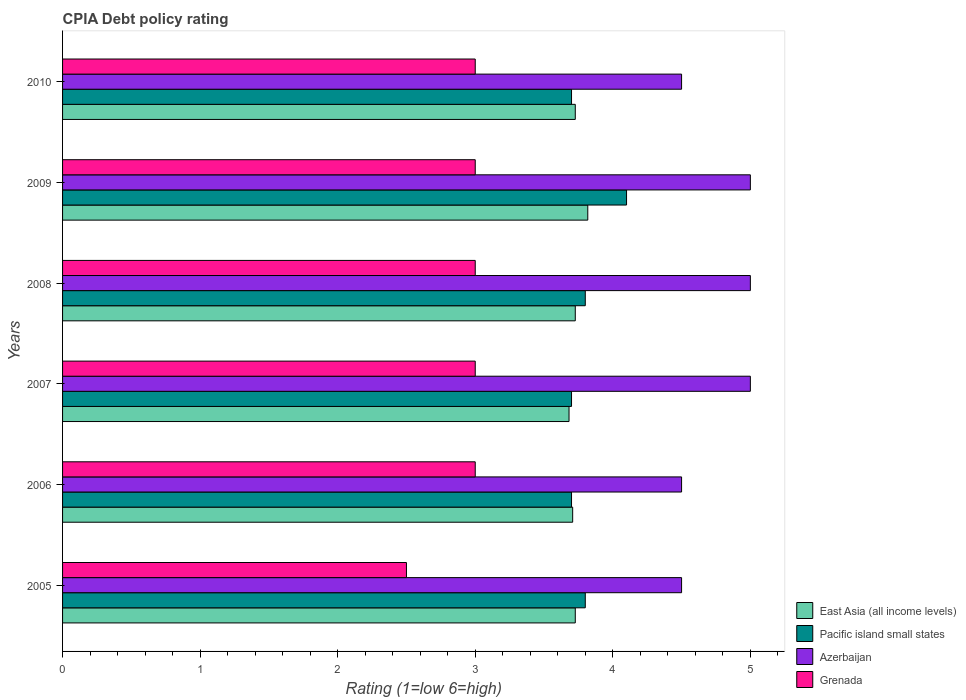How many different coloured bars are there?
Keep it short and to the point. 4. Are the number of bars per tick equal to the number of legend labels?
Make the answer very short. Yes. Are the number of bars on each tick of the Y-axis equal?
Your answer should be very brief. Yes. How many bars are there on the 2nd tick from the bottom?
Your response must be concise. 4. What is the label of the 4th group of bars from the top?
Give a very brief answer. 2007. In how many cases, is the number of bars for a given year not equal to the number of legend labels?
Your response must be concise. 0. In which year was the CPIA rating in Grenada minimum?
Keep it short and to the point. 2005. What is the total CPIA rating in Pacific island small states in the graph?
Your answer should be very brief. 22.8. What is the difference between the CPIA rating in Grenada in 2010 and the CPIA rating in East Asia (all income levels) in 2007?
Give a very brief answer. -0.68. What is the average CPIA rating in Grenada per year?
Provide a short and direct response. 2.92. In the year 2007, what is the difference between the CPIA rating in Azerbaijan and CPIA rating in Pacific island small states?
Offer a very short reply. 1.3. In how many years, is the CPIA rating in Grenada greater than 2.8 ?
Keep it short and to the point. 5. What is the ratio of the CPIA rating in Azerbaijan in 2009 to that in 2010?
Offer a terse response. 1.11. Is the CPIA rating in Grenada in 2005 less than that in 2007?
Offer a very short reply. Yes. What is the difference between the highest and the second highest CPIA rating in Pacific island small states?
Your answer should be compact. 0.3. Is it the case that in every year, the sum of the CPIA rating in East Asia (all income levels) and CPIA rating in Azerbaijan is greater than the sum of CPIA rating in Grenada and CPIA rating in Pacific island small states?
Your answer should be compact. Yes. What does the 3rd bar from the top in 2007 represents?
Make the answer very short. Pacific island small states. What does the 1st bar from the bottom in 2005 represents?
Provide a succinct answer. East Asia (all income levels). What is the difference between two consecutive major ticks on the X-axis?
Provide a succinct answer. 1. Are the values on the major ticks of X-axis written in scientific E-notation?
Give a very brief answer. No. Does the graph contain any zero values?
Keep it short and to the point. No. Where does the legend appear in the graph?
Make the answer very short. Bottom right. How many legend labels are there?
Ensure brevity in your answer.  4. What is the title of the graph?
Your answer should be very brief. CPIA Debt policy rating. What is the label or title of the Y-axis?
Keep it short and to the point. Years. What is the Rating (1=low 6=high) in East Asia (all income levels) in 2005?
Keep it short and to the point. 3.73. What is the Rating (1=low 6=high) in Pacific island small states in 2005?
Your answer should be compact. 3.8. What is the Rating (1=low 6=high) of East Asia (all income levels) in 2006?
Ensure brevity in your answer.  3.71. What is the Rating (1=low 6=high) of Grenada in 2006?
Give a very brief answer. 3. What is the Rating (1=low 6=high) of East Asia (all income levels) in 2007?
Your response must be concise. 3.68. What is the Rating (1=low 6=high) in Pacific island small states in 2007?
Make the answer very short. 3.7. What is the Rating (1=low 6=high) in Azerbaijan in 2007?
Offer a terse response. 5. What is the Rating (1=low 6=high) in East Asia (all income levels) in 2008?
Your answer should be compact. 3.73. What is the Rating (1=low 6=high) of Pacific island small states in 2008?
Provide a short and direct response. 3.8. What is the Rating (1=low 6=high) in Grenada in 2008?
Your response must be concise. 3. What is the Rating (1=low 6=high) in East Asia (all income levels) in 2009?
Your answer should be very brief. 3.82. What is the Rating (1=low 6=high) of Pacific island small states in 2009?
Offer a terse response. 4.1. What is the Rating (1=low 6=high) of Azerbaijan in 2009?
Your response must be concise. 5. What is the Rating (1=low 6=high) of Grenada in 2009?
Your response must be concise. 3. What is the Rating (1=low 6=high) in East Asia (all income levels) in 2010?
Offer a very short reply. 3.73. What is the Rating (1=low 6=high) of Azerbaijan in 2010?
Your answer should be compact. 4.5. What is the Rating (1=low 6=high) in Grenada in 2010?
Keep it short and to the point. 3. Across all years, what is the maximum Rating (1=low 6=high) of East Asia (all income levels)?
Give a very brief answer. 3.82. Across all years, what is the maximum Rating (1=low 6=high) of Pacific island small states?
Your answer should be compact. 4.1. Across all years, what is the minimum Rating (1=low 6=high) of East Asia (all income levels)?
Offer a very short reply. 3.68. Across all years, what is the minimum Rating (1=low 6=high) of Grenada?
Provide a short and direct response. 2.5. What is the total Rating (1=low 6=high) in East Asia (all income levels) in the graph?
Keep it short and to the point. 22.39. What is the total Rating (1=low 6=high) in Pacific island small states in the graph?
Ensure brevity in your answer.  22.8. What is the total Rating (1=low 6=high) of Azerbaijan in the graph?
Provide a short and direct response. 28.5. What is the total Rating (1=low 6=high) of Grenada in the graph?
Ensure brevity in your answer.  17.5. What is the difference between the Rating (1=low 6=high) in East Asia (all income levels) in 2005 and that in 2006?
Your answer should be compact. 0.02. What is the difference between the Rating (1=low 6=high) in East Asia (all income levels) in 2005 and that in 2007?
Keep it short and to the point. 0.05. What is the difference between the Rating (1=low 6=high) in Pacific island small states in 2005 and that in 2007?
Your answer should be compact. 0.1. What is the difference between the Rating (1=low 6=high) of Azerbaijan in 2005 and that in 2007?
Give a very brief answer. -0.5. What is the difference between the Rating (1=low 6=high) of East Asia (all income levels) in 2005 and that in 2008?
Provide a succinct answer. 0. What is the difference between the Rating (1=low 6=high) of Pacific island small states in 2005 and that in 2008?
Your answer should be compact. 0. What is the difference between the Rating (1=low 6=high) of Grenada in 2005 and that in 2008?
Provide a short and direct response. -0.5. What is the difference between the Rating (1=low 6=high) in East Asia (all income levels) in 2005 and that in 2009?
Make the answer very short. -0.09. What is the difference between the Rating (1=low 6=high) in Grenada in 2005 and that in 2009?
Keep it short and to the point. -0.5. What is the difference between the Rating (1=low 6=high) in Pacific island small states in 2005 and that in 2010?
Your response must be concise. 0.1. What is the difference between the Rating (1=low 6=high) in Azerbaijan in 2005 and that in 2010?
Offer a terse response. 0. What is the difference between the Rating (1=low 6=high) in Grenada in 2005 and that in 2010?
Your answer should be compact. -0.5. What is the difference between the Rating (1=low 6=high) of East Asia (all income levels) in 2006 and that in 2007?
Ensure brevity in your answer.  0.03. What is the difference between the Rating (1=low 6=high) in East Asia (all income levels) in 2006 and that in 2008?
Your answer should be compact. -0.02. What is the difference between the Rating (1=low 6=high) in Pacific island small states in 2006 and that in 2008?
Provide a succinct answer. -0.1. What is the difference between the Rating (1=low 6=high) in Azerbaijan in 2006 and that in 2008?
Offer a very short reply. -0.5. What is the difference between the Rating (1=low 6=high) in East Asia (all income levels) in 2006 and that in 2009?
Provide a short and direct response. -0.11. What is the difference between the Rating (1=low 6=high) in Grenada in 2006 and that in 2009?
Your answer should be compact. 0. What is the difference between the Rating (1=low 6=high) in East Asia (all income levels) in 2006 and that in 2010?
Your answer should be compact. -0.02. What is the difference between the Rating (1=low 6=high) in Azerbaijan in 2006 and that in 2010?
Make the answer very short. 0. What is the difference between the Rating (1=low 6=high) in Grenada in 2006 and that in 2010?
Make the answer very short. 0. What is the difference between the Rating (1=low 6=high) in East Asia (all income levels) in 2007 and that in 2008?
Your answer should be compact. -0.05. What is the difference between the Rating (1=low 6=high) in Azerbaijan in 2007 and that in 2008?
Provide a short and direct response. 0. What is the difference between the Rating (1=low 6=high) in East Asia (all income levels) in 2007 and that in 2009?
Provide a short and direct response. -0.14. What is the difference between the Rating (1=low 6=high) in Azerbaijan in 2007 and that in 2009?
Your answer should be compact. 0. What is the difference between the Rating (1=low 6=high) of East Asia (all income levels) in 2007 and that in 2010?
Provide a succinct answer. -0.05. What is the difference between the Rating (1=low 6=high) in Azerbaijan in 2007 and that in 2010?
Provide a succinct answer. 0.5. What is the difference between the Rating (1=low 6=high) of East Asia (all income levels) in 2008 and that in 2009?
Keep it short and to the point. -0.09. What is the difference between the Rating (1=low 6=high) of Pacific island small states in 2008 and that in 2009?
Keep it short and to the point. -0.3. What is the difference between the Rating (1=low 6=high) of Azerbaijan in 2008 and that in 2009?
Your response must be concise. 0. What is the difference between the Rating (1=low 6=high) in Grenada in 2008 and that in 2009?
Give a very brief answer. 0. What is the difference between the Rating (1=low 6=high) in Pacific island small states in 2008 and that in 2010?
Ensure brevity in your answer.  0.1. What is the difference between the Rating (1=low 6=high) of Grenada in 2008 and that in 2010?
Give a very brief answer. 0. What is the difference between the Rating (1=low 6=high) in East Asia (all income levels) in 2009 and that in 2010?
Your response must be concise. 0.09. What is the difference between the Rating (1=low 6=high) of East Asia (all income levels) in 2005 and the Rating (1=low 6=high) of Pacific island small states in 2006?
Make the answer very short. 0.03. What is the difference between the Rating (1=low 6=high) of East Asia (all income levels) in 2005 and the Rating (1=low 6=high) of Azerbaijan in 2006?
Offer a terse response. -0.77. What is the difference between the Rating (1=low 6=high) of East Asia (all income levels) in 2005 and the Rating (1=low 6=high) of Grenada in 2006?
Ensure brevity in your answer.  0.73. What is the difference between the Rating (1=low 6=high) in Pacific island small states in 2005 and the Rating (1=low 6=high) in Grenada in 2006?
Your answer should be compact. 0.8. What is the difference between the Rating (1=low 6=high) of East Asia (all income levels) in 2005 and the Rating (1=low 6=high) of Pacific island small states in 2007?
Provide a short and direct response. 0.03. What is the difference between the Rating (1=low 6=high) in East Asia (all income levels) in 2005 and the Rating (1=low 6=high) in Azerbaijan in 2007?
Your answer should be very brief. -1.27. What is the difference between the Rating (1=low 6=high) in East Asia (all income levels) in 2005 and the Rating (1=low 6=high) in Grenada in 2007?
Your answer should be very brief. 0.73. What is the difference between the Rating (1=low 6=high) in Pacific island small states in 2005 and the Rating (1=low 6=high) in Azerbaijan in 2007?
Ensure brevity in your answer.  -1.2. What is the difference between the Rating (1=low 6=high) of East Asia (all income levels) in 2005 and the Rating (1=low 6=high) of Pacific island small states in 2008?
Give a very brief answer. -0.07. What is the difference between the Rating (1=low 6=high) in East Asia (all income levels) in 2005 and the Rating (1=low 6=high) in Azerbaijan in 2008?
Keep it short and to the point. -1.27. What is the difference between the Rating (1=low 6=high) in East Asia (all income levels) in 2005 and the Rating (1=low 6=high) in Grenada in 2008?
Offer a terse response. 0.73. What is the difference between the Rating (1=low 6=high) in Pacific island small states in 2005 and the Rating (1=low 6=high) in Grenada in 2008?
Make the answer very short. 0.8. What is the difference between the Rating (1=low 6=high) of East Asia (all income levels) in 2005 and the Rating (1=low 6=high) of Pacific island small states in 2009?
Give a very brief answer. -0.37. What is the difference between the Rating (1=low 6=high) of East Asia (all income levels) in 2005 and the Rating (1=low 6=high) of Azerbaijan in 2009?
Give a very brief answer. -1.27. What is the difference between the Rating (1=low 6=high) in East Asia (all income levels) in 2005 and the Rating (1=low 6=high) in Grenada in 2009?
Your answer should be very brief. 0.73. What is the difference between the Rating (1=low 6=high) in Pacific island small states in 2005 and the Rating (1=low 6=high) in Azerbaijan in 2009?
Keep it short and to the point. -1.2. What is the difference between the Rating (1=low 6=high) of Pacific island small states in 2005 and the Rating (1=low 6=high) of Grenada in 2009?
Offer a terse response. 0.8. What is the difference between the Rating (1=low 6=high) of Azerbaijan in 2005 and the Rating (1=low 6=high) of Grenada in 2009?
Make the answer very short. 1.5. What is the difference between the Rating (1=low 6=high) in East Asia (all income levels) in 2005 and the Rating (1=low 6=high) in Pacific island small states in 2010?
Provide a short and direct response. 0.03. What is the difference between the Rating (1=low 6=high) in East Asia (all income levels) in 2005 and the Rating (1=low 6=high) in Azerbaijan in 2010?
Your answer should be very brief. -0.77. What is the difference between the Rating (1=low 6=high) of East Asia (all income levels) in 2005 and the Rating (1=low 6=high) of Grenada in 2010?
Provide a short and direct response. 0.73. What is the difference between the Rating (1=low 6=high) in East Asia (all income levels) in 2006 and the Rating (1=low 6=high) in Pacific island small states in 2007?
Your answer should be compact. 0.01. What is the difference between the Rating (1=low 6=high) in East Asia (all income levels) in 2006 and the Rating (1=low 6=high) in Azerbaijan in 2007?
Make the answer very short. -1.29. What is the difference between the Rating (1=low 6=high) of East Asia (all income levels) in 2006 and the Rating (1=low 6=high) of Grenada in 2007?
Offer a terse response. 0.71. What is the difference between the Rating (1=low 6=high) in Pacific island small states in 2006 and the Rating (1=low 6=high) in Grenada in 2007?
Offer a very short reply. 0.7. What is the difference between the Rating (1=low 6=high) of East Asia (all income levels) in 2006 and the Rating (1=low 6=high) of Pacific island small states in 2008?
Your response must be concise. -0.09. What is the difference between the Rating (1=low 6=high) of East Asia (all income levels) in 2006 and the Rating (1=low 6=high) of Azerbaijan in 2008?
Keep it short and to the point. -1.29. What is the difference between the Rating (1=low 6=high) in East Asia (all income levels) in 2006 and the Rating (1=low 6=high) in Grenada in 2008?
Provide a short and direct response. 0.71. What is the difference between the Rating (1=low 6=high) in East Asia (all income levels) in 2006 and the Rating (1=low 6=high) in Pacific island small states in 2009?
Keep it short and to the point. -0.39. What is the difference between the Rating (1=low 6=high) of East Asia (all income levels) in 2006 and the Rating (1=low 6=high) of Azerbaijan in 2009?
Make the answer very short. -1.29. What is the difference between the Rating (1=low 6=high) in East Asia (all income levels) in 2006 and the Rating (1=low 6=high) in Grenada in 2009?
Your response must be concise. 0.71. What is the difference between the Rating (1=low 6=high) of East Asia (all income levels) in 2006 and the Rating (1=low 6=high) of Pacific island small states in 2010?
Keep it short and to the point. 0.01. What is the difference between the Rating (1=low 6=high) in East Asia (all income levels) in 2006 and the Rating (1=low 6=high) in Azerbaijan in 2010?
Keep it short and to the point. -0.79. What is the difference between the Rating (1=low 6=high) of East Asia (all income levels) in 2006 and the Rating (1=low 6=high) of Grenada in 2010?
Provide a succinct answer. 0.71. What is the difference between the Rating (1=low 6=high) of Pacific island small states in 2006 and the Rating (1=low 6=high) of Azerbaijan in 2010?
Your answer should be compact. -0.8. What is the difference between the Rating (1=low 6=high) in Pacific island small states in 2006 and the Rating (1=low 6=high) in Grenada in 2010?
Your response must be concise. 0.7. What is the difference between the Rating (1=low 6=high) of East Asia (all income levels) in 2007 and the Rating (1=low 6=high) of Pacific island small states in 2008?
Your answer should be compact. -0.12. What is the difference between the Rating (1=low 6=high) in East Asia (all income levels) in 2007 and the Rating (1=low 6=high) in Azerbaijan in 2008?
Your response must be concise. -1.32. What is the difference between the Rating (1=low 6=high) in East Asia (all income levels) in 2007 and the Rating (1=low 6=high) in Grenada in 2008?
Offer a very short reply. 0.68. What is the difference between the Rating (1=low 6=high) in Pacific island small states in 2007 and the Rating (1=low 6=high) in Azerbaijan in 2008?
Offer a terse response. -1.3. What is the difference between the Rating (1=low 6=high) of East Asia (all income levels) in 2007 and the Rating (1=low 6=high) of Pacific island small states in 2009?
Keep it short and to the point. -0.42. What is the difference between the Rating (1=low 6=high) of East Asia (all income levels) in 2007 and the Rating (1=low 6=high) of Azerbaijan in 2009?
Your response must be concise. -1.32. What is the difference between the Rating (1=low 6=high) of East Asia (all income levels) in 2007 and the Rating (1=low 6=high) of Grenada in 2009?
Your answer should be very brief. 0.68. What is the difference between the Rating (1=low 6=high) in Pacific island small states in 2007 and the Rating (1=low 6=high) in Grenada in 2009?
Keep it short and to the point. 0.7. What is the difference between the Rating (1=low 6=high) in East Asia (all income levels) in 2007 and the Rating (1=low 6=high) in Pacific island small states in 2010?
Offer a terse response. -0.02. What is the difference between the Rating (1=low 6=high) in East Asia (all income levels) in 2007 and the Rating (1=low 6=high) in Azerbaijan in 2010?
Provide a short and direct response. -0.82. What is the difference between the Rating (1=low 6=high) in East Asia (all income levels) in 2007 and the Rating (1=low 6=high) in Grenada in 2010?
Offer a terse response. 0.68. What is the difference between the Rating (1=low 6=high) of Pacific island small states in 2007 and the Rating (1=low 6=high) of Grenada in 2010?
Your response must be concise. 0.7. What is the difference between the Rating (1=low 6=high) of East Asia (all income levels) in 2008 and the Rating (1=low 6=high) of Pacific island small states in 2009?
Make the answer very short. -0.37. What is the difference between the Rating (1=low 6=high) of East Asia (all income levels) in 2008 and the Rating (1=low 6=high) of Azerbaijan in 2009?
Offer a very short reply. -1.27. What is the difference between the Rating (1=low 6=high) in East Asia (all income levels) in 2008 and the Rating (1=low 6=high) in Grenada in 2009?
Provide a short and direct response. 0.73. What is the difference between the Rating (1=low 6=high) in Pacific island small states in 2008 and the Rating (1=low 6=high) in Azerbaijan in 2009?
Give a very brief answer. -1.2. What is the difference between the Rating (1=low 6=high) of East Asia (all income levels) in 2008 and the Rating (1=low 6=high) of Pacific island small states in 2010?
Your answer should be compact. 0.03. What is the difference between the Rating (1=low 6=high) in East Asia (all income levels) in 2008 and the Rating (1=low 6=high) in Azerbaijan in 2010?
Provide a succinct answer. -0.77. What is the difference between the Rating (1=low 6=high) of East Asia (all income levels) in 2008 and the Rating (1=low 6=high) of Grenada in 2010?
Keep it short and to the point. 0.73. What is the difference between the Rating (1=low 6=high) of East Asia (all income levels) in 2009 and the Rating (1=low 6=high) of Pacific island small states in 2010?
Keep it short and to the point. 0.12. What is the difference between the Rating (1=low 6=high) in East Asia (all income levels) in 2009 and the Rating (1=low 6=high) in Azerbaijan in 2010?
Your answer should be compact. -0.68. What is the difference between the Rating (1=low 6=high) of East Asia (all income levels) in 2009 and the Rating (1=low 6=high) of Grenada in 2010?
Ensure brevity in your answer.  0.82. What is the difference between the Rating (1=low 6=high) of Azerbaijan in 2009 and the Rating (1=low 6=high) of Grenada in 2010?
Offer a terse response. 2. What is the average Rating (1=low 6=high) in East Asia (all income levels) per year?
Offer a terse response. 3.73. What is the average Rating (1=low 6=high) in Azerbaijan per year?
Ensure brevity in your answer.  4.75. What is the average Rating (1=low 6=high) in Grenada per year?
Your answer should be compact. 2.92. In the year 2005, what is the difference between the Rating (1=low 6=high) in East Asia (all income levels) and Rating (1=low 6=high) in Pacific island small states?
Your response must be concise. -0.07. In the year 2005, what is the difference between the Rating (1=low 6=high) in East Asia (all income levels) and Rating (1=low 6=high) in Azerbaijan?
Your answer should be compact. -0.77. In the year 2005, what is the difference between the Rating (1=low 6=high) in East Asia (all income levels) and Rating (1=low 6=high) in Grenada?
Your answer should be compact. 1.23. In the year 2005, what is the difference between the Rating (1=low 6=high) of Pacific island small states and Rating (1=low 6=high) of Azerbaijan?
Offer a very short reply. -0.7. In the year 2006, what is the difference between the Rating (1=low 6=high) in East Asia (all income levels) and Rating (1=low 6=high) in Pacific island small states?
Offer a very short reply. 0.01. In the year 2006, what is the difference between the Rating (1=low 6=high) in East Asia (all income levels) and Rating (1=low 6=high) in Azerbaijan?
Make the answer very short. -0.79. In the year 2006, what is the difference between the Rating (1=low 6=high) of East Asia (all income levels) and Rating (1=low 6=high) of Grenada?
Provide a short and direct response. 0.71. In the year 2006, what is the difference between the Rating (1=low 6=high) of Pacific island small states and Rating (1=low 6=high) of Grenada?
Make the answer very short. 0.7. In the year 2007, what is the difference between the Rating (1=low 6=high) of East Asia (all income levels) and Rating (1=low 6=high) of Pacific island small states?
Ensure brevity in your answer.  -0.02. In the year 2007, what is the difference between the Rating (1=low 6=high) of East Asia (all income levels) and Rating (1=low 6=high) of Azerbaijan?
Give a very brief answer. -1.32. In the year 2007, what is the difference between the Rating (1=low 6=high) in East Asia (all income levels) and Rating (1=low 6=high) in Grenada?
Provide a succinct answer. 0.68. In the year 2007, what is the difference between the Rating (1=low 6=high) in Pacific island small states and Rating (1=low 6=high) in Azerbaijan?
Give a very brief answer. -1.3. In the year 2007, what is the difference between the Rating (1=low 6=high) in Pacific island small states and Rating (1=low 6=high) in Grenada?
Your answer should be compact. 0.7. In the year 2007, what is the difference between the Rating (1=low 6=high) of Azerbaijan and Rating (1=low 6=high) of Grenada?
Provide a short and direct response. 2. In the year 2008, what is the difference between the Rating (1=low 6=high) in East Asia (all income levels) and Rating (1=low 6=high) in Pacific island small states?
Your response must be concise. -0.07. In the year 2008, what is the difference between the Rating (1=low 6=high) in East Asia (all income levels) and Rating (1=low 6=high) in Azerbaijan?
Offer a terse response. -1.27. In the year 2008, what is the difference between the Rating (1=low 6=high) in East Asia (all income levels) and Rating (1=low 6=high) in Grenada?
Ensure brevity in your answer.  0.73. In the year 2008, what is the difference between the Rating (1=low 6=high) of Pacific island small states and Rating (1=low 6=high) of Azerbaijan?
Offer a terse response. -1.2. In the year 2008, what is the difference between the Rating (1=low 6=high) in Pacific island small states and Rating (1=low 6=high) in Grenada?
Make the answer very short. 0.8. In the year 2008, what is the difference between the Rating (1=low 6=high) of Azerbaijan and Rating (1=low 6=high) of Grenada?
Keep it short and to the point. 2. In the year 2009, what is the difference between the Rating (1=low 6=high) in East Asia (all income levels) and Rating (1=low 6=high) in Pacific island small states?
Offer a terse response. -0.28. In the year 2009, what is the difference between the Rating (1=low 6=high) of East Asia (all income levels) and Rating (1=low 6=high) of Azerbaijan?
Provide a short and direct response. -1.18. In the year 2009, what is the difference between the Rating (1=low 6=high) of East Asia (all income levels) and Rating (1=low 6=high) of Grenada?
Keep it short and to the point. 0.82. In the year 2009, what is the difference between the Rating (1=low 6=high) in Pacific island small states and Rating (1=low 6=high) in Grenada?
Provide a short and direct response. 1.1. In the year 2009, what is the difference between the Rating (1=low 6=high) in Azerbaijan and Rating (1=low 6=high) in Grenada?
Provide a short and direct response. 2. In the year 2010, what is the difference between the Rating (1=low 6=high) of East Asia (all income levels) and Rating (1=low 6=high) of Pacific island small states?
Your answer should be very brief. 0.03. In the year 2010, what is the difference between the Rating (1=low 6=high) in East Asia (all income levels) and Rating (1=low 6=high) in Azerbaijan?
Provide a succinct answer. -0.77. In the year 2010, what is the difference between the Rating (1=low 6=high) of East Asia (all income levels) and Rating (1=low 6=high) of Grenada?
Give a very brief answer. 0.73. In the year 2010, what is the difference between the Rating (1=low 6=high) in Pacific island small states and Rating (1=low 6=high) in Azerbaijan?
Keep it short and to the point. -0.8. In the year 2010, what is the difference between the Rating (1=low 6=high) of Pacific island small states and Rating (1=low 6=high) of Grenada?
Make the answer very short. 0.7. What is the ratio of the Rating (1=low 6=high) of East Asia (all income levels) in 2005 to that in 2006?
Provide a short and direct response. 1.01. What is the ratio of the Rating (1=low 6=high) of Grenada in 2005 to that in 2006?
Provide a short and direct response. 0.83. What is the ratio of the Rating (1=low 6=high) in East Asia (all income levels) in 2005 to that in 2007?
Provide a short and direct response. 1.01. What is the ratio of the Rating (1=low 6=high) in Pacific island small states in 2005 to that in 2007?
Provide a short and direct response. 1.03. What is the ratio of the Rating (1=low 6=high) of East Asia (all income levels) in 2005 to that in 2008?
Make the answer very short. 1. What is the ratio of the Rating (1=low 6=high) in East Asia (all income levels) in 2005 to that in 2009?
Ensure brevity in your answer.  0.98. What is the ratio of the Rating (1=low 6=high) in Pacific island small states in 2005 to that in 2009?
Make the answer very short. 0.93. What is the ratio of the Rating (1=low 6=high) in Azerbaijan in 2005 to that in 2009?
Your response must be concise. 0.9. What is the ratio of the Rating (1=low 6=high) of Grenada in 2005 to that in 2009?
Your response must be concise. 0.83. What is the ratio of the Rating (1=low 6=high) of Azerbaijan in 2005 to that in 2010?
Make the answer very short. 1. What is the ratio of the Rating (1=low 6=high) in Pacific island small states in 2006 to that in 2007?
Your answer should be very brief. 1. What is the ratio of the Rating (1=low 6=high) in Pacific island small states in 2006 to that in 2008?
Make the answer very short. 0.97. What is the ratio of the Rating (1=low 6=high) of Azerbaijan in 2006 to that in 2008?
Provide a short and direct response. 0.9. What is the ratio of the Rating (1=low 6=high) in Grenada in 2006 to that in 2008?
Your response must be concise. 1. What is the ratio of the Rating (1=low 6=high) of East Asia (all income levels) in 2006 to that in 2009?
Make the answer very short. 0.97. What is the ratio of the Rating (1=low 6=high) in Pacific island small states in 2006 to that in 2009?
Make the answer very short. 0.9. What is the ratio of the Rating (1=low 6=high) of Grenada in 2006 to that in 2009?
Make the answer very short. 1. What is the ratio of the Rating (1=low 6=high) in East Asia (all income levels) in 2006 to that in 2010?
Make the answer very short. 0.99. What is the ratio of the Rating (1=low 6=high) in Pacific island small states in 2006 to that in 2010?
Your answer should be very brief. 1. What is the ratio of the Rating (1=low 6=high) in Azerbaijan in 2006 to that in 2010?
Offer a terse response. 1. What is the ratio of the Rating (1=low 6=high) in East Asia (all income levels) in 2007 to that in 2008?
Offer a terse response. 0.99. What is the ratio of the Rating (1=low 6=high) in Pacific island small states in 2007 to that in 2008?
Your response must be concise. 0.97. What is the ratio of the Rating (1=low 6=high) of Grenada in 2007 to that in 2008?
Your answer should be compact. 1. What is the ratio of the Rating (1=low 6=high) in East Asia (all income levels) in 2007 to that in 2009?
Offer a terse response. 0.96. What is the ratio of the Rating (1=low 6=high) in Pacific island small states in 2007 to that in 2009?
Your answer should be very brief. 0.9. What is the ratio of the Rating (1=low 6=high) of Azerbaijan in 2007 to that in 2009?
Provide a short and direct response. 1. What is the ratio of the Rating (1=low 6=high) of Grenada in 2007 to that in 2009?
Keep it short and to the point. 1. What is the ratio of the Rating (1=low 6=high) of Grenada in 2007 to that in 2010?
Provide a short and direct response. 1. What is the ratio of the Rating (1=low 6=high) in East Asia (all income levels) in 2008 to that in 2009?
Offer a very short reply. 0.98. What is the ratio of the Rating (1=low 6=high) in Pacific island small states in 2008 to that in 2009?
Ensure brevity in your answer.  0.93. What is the ratio of the Rating (1=low 6=high) of Azerbaijan in 2008 to that in 2009?
Ensure brevity in your answer.  1. What is the ratio of the Rating (1=low 6=high) of Grenada in 2008 to that in 2009?
Offer a terse response. 1. What is the ratio of the Rating (1=low 6=high) in Azerbaijan in 2008 to that in 2010?
Provide a succinct answer. 1.11. What is the ratio of the Rating (1=low 6=high) in East Asia (all income levels) in 2009 to that in 2010?
Ensure brevity in your answer.  1.02. What is the ratio of the Rating (1=low 6=high) of Pacific island small states in 2009 to that in 2010?
Your answer should be compact. 1.11. What is the difference between the highest and the second highest Rating (1=low 6=high) of East Asia (all income levels)?
Provide a short and direct response. 0.09. What is the difference between the highest and the second highest Rating (1=low 6=high) of Pacific island small states?
Make the answer very short. 0.3. What is the difference between the highest and the second highest Rating (1=low 6=high) in Grenada?
Your answer should be compact. 0. What is the difference between the highest and the lowest Rating (1=low 6=high) of East Asia (all income levels)?
Your answer should be very brief. 0.14. What is the difference between the highest and the lowest Rating (1=low 6=high) in Pacific island small states?
Ensure brevity in your answer.  0.4. What is the difference between the highest and the lowest Rating (1=low 6=high) of Azerbaijan?
Make the answer very short. 0.5. 